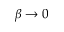Convert formula to latex. <formula><loc_0><loc_0><loc_500><loc_500>\beta \rightarrow 0</formula> 